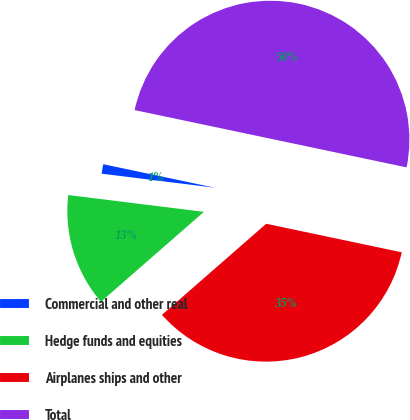Convert chart. <chart><loc_0><loc_0><loc_500><loc_500><pie_chart><fcel>Commercial and other real<fcel>Hedge funds and equities<fcel>Airplanes ships and other<fcel>Total<nl><fcel>1.34%<fcel>13.39%<fcel>35.27%<fcel>50.0%<nl></chart> 